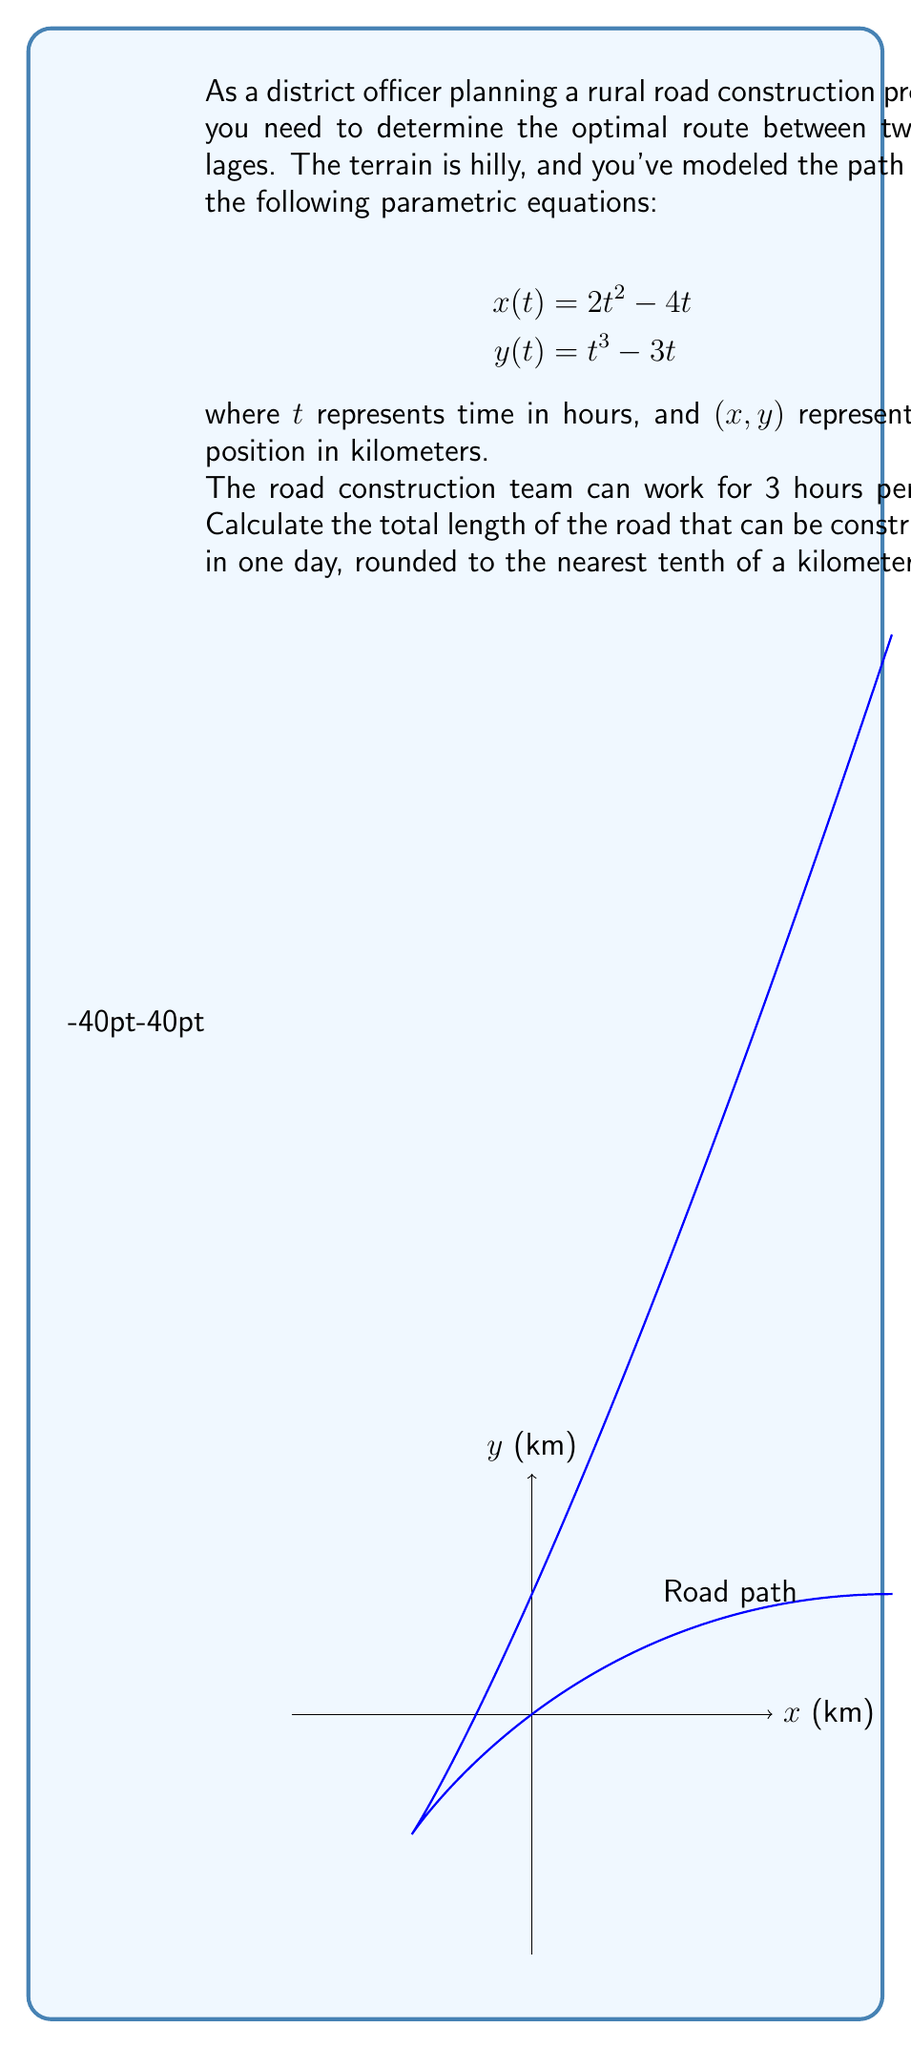Provide a solution to this math problem. To solve this problem, we need to follow these steps:

1) The path length is given by the arc length formula for parametric equations:

   $$L = \int_a^b \sqrt{\left(\frac{dx}{dt}\right)^2 + \left(\frac{dy}{dt}\right)^2} dt$$

2) First, we need to find $\frac{dx}{dt}$ and $\frac{dy}{dt}$:
   
   $$\frac{dx}{dt} = 4t - 4$$
   $$\frac{dy}{dt} = 3t^2 - 3$$

3) Substituting these into the arc length formula:

   $$L = \int_0^3 \sqrt{(4t - 4)^2 + (3t^2 - 3)^2} dt$$

4) Simplifying under the square root:

   $$L = \int_0^3 \sqrt{16t^2 - 32t + 16 + 9t^4 - 18t^2 + 9} dt$$
   $$L = \int_0^3 \sqrt{9t^4 - 2t^2 - 32t + 25} dt$$

5) This integral is complex to solve analytically. We can use numerical integration methods, such as Simpson's rule or a computer algebra system, to evaluate it.

6) Using a numerical integration method, we find that:

   $$L \approx 10.7363 \text{ km}$$

7) Rounding to the nearest tenth:

   $$L \approx 10.7 \text{ km}$$

Thus, in one day (3 hours of work), approximately 10.7 km of road can be constructed.
Answer: 10.7 km 